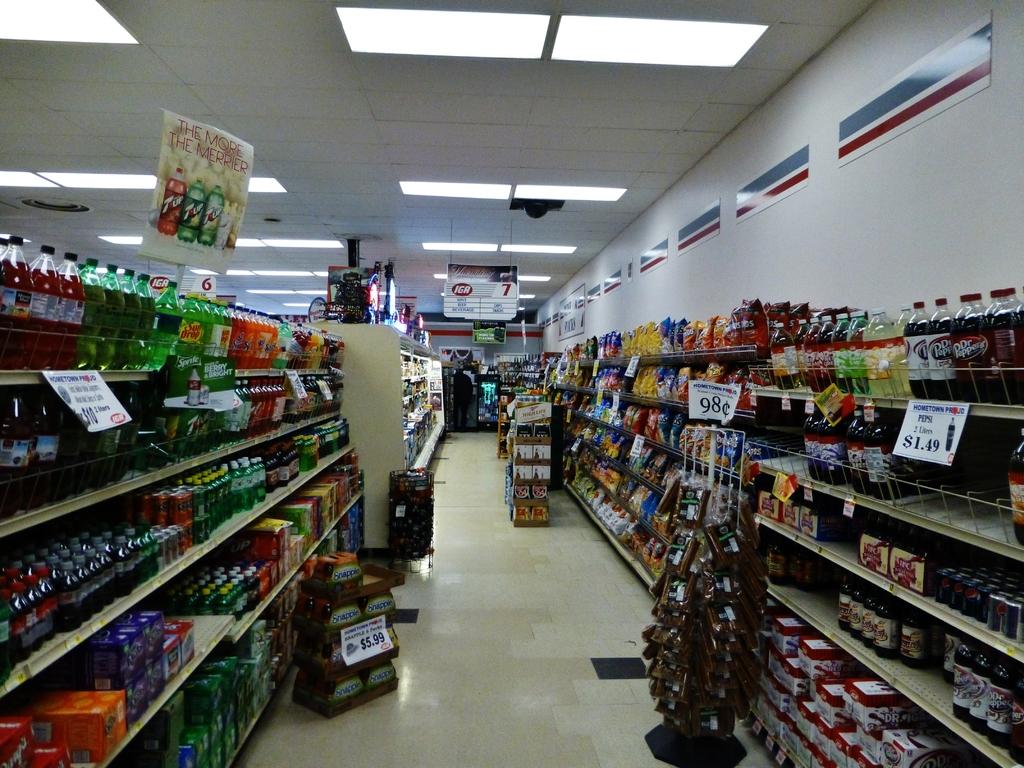Whats the sale price of the dr. pepper?
Offer a terse response. 1.49. 